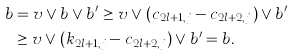<formula> <loc_0><loc_0><loc_500><loc_500>b & = v \vee b \vee b ^ { \prime } \geq v \vee ( c _ { 2 l + 1 , j } - c _ { 2 l + 2 , j } ) \vee b ^ { \prime } \\ & \geq v \vee ( k _ { 2 l + 1 , j } - c _ { 2 l + 2 , j } ) \vee b ^ { \prime } = b .</formula> 